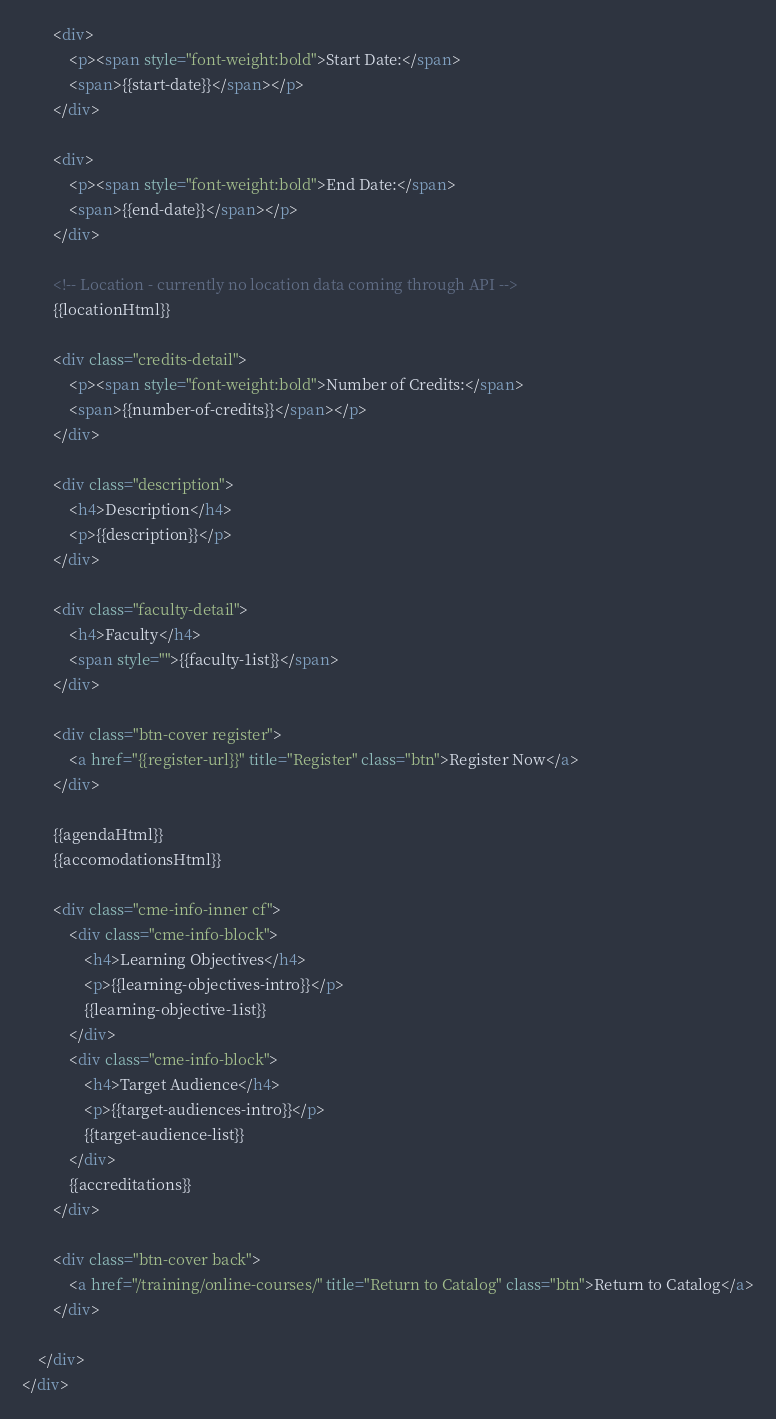Convert code to text. <code><loc_0><loc_0><loc_500><loc_500><_HTML_>
		<div>
			<p><span style="font-weight:bold">Start Date:</span>
			<span>{{start-date}}</span></p>
		</div>

		<div>
			<p><span style="font-weight:bold">End Date:</span>
			<span>{{end-date}}</span></p>
		</div>

		<!-- Location - currently no location data coming through API -->
		{{locationHtml}}

		<div class="credits-detail">
			<p><span style="font-weight:bold">Number of Credits:</span>
			<span>{{number-of-credits}}</span></p>
		</div>

		<div class="description">
			<h4>Description</h4>
			<p>{{description}}</p>
		</div>

		<div class="faculty-detail">
			<h4>Faculty</h4>
			<span style="">{{faculty-1ist}}</span>
		</div>

		<div class="btn-cover register">
			<a href="{{register-url}}" title="Register" class="btn">Register Now</a>
		</div>

		{{agendaHtml}}
		{{accomodationsHtml}}

		<div class="cme-info-inner cf">
			<div class="cme-info-block">
				<h4>Learning Objectives</h4>
				<p>{{learning-objectives-intro}}</p>
				{{learning-objective-1ist}}
			</div>
			<div class="cme-info-block">
				<h4>Target Audience</h4>
				<p>{{target-audiences-intro}}</p>
				{{target-audience-list}}
			</div>
			{{accreditations}}
		</div>

    	<div class="btn-cover back">
			<a href="/training/online-courses/" title="Return to Catalog" class="btn">Return to Catalog</a>
		</div>

	</div>
</div>
</code> 